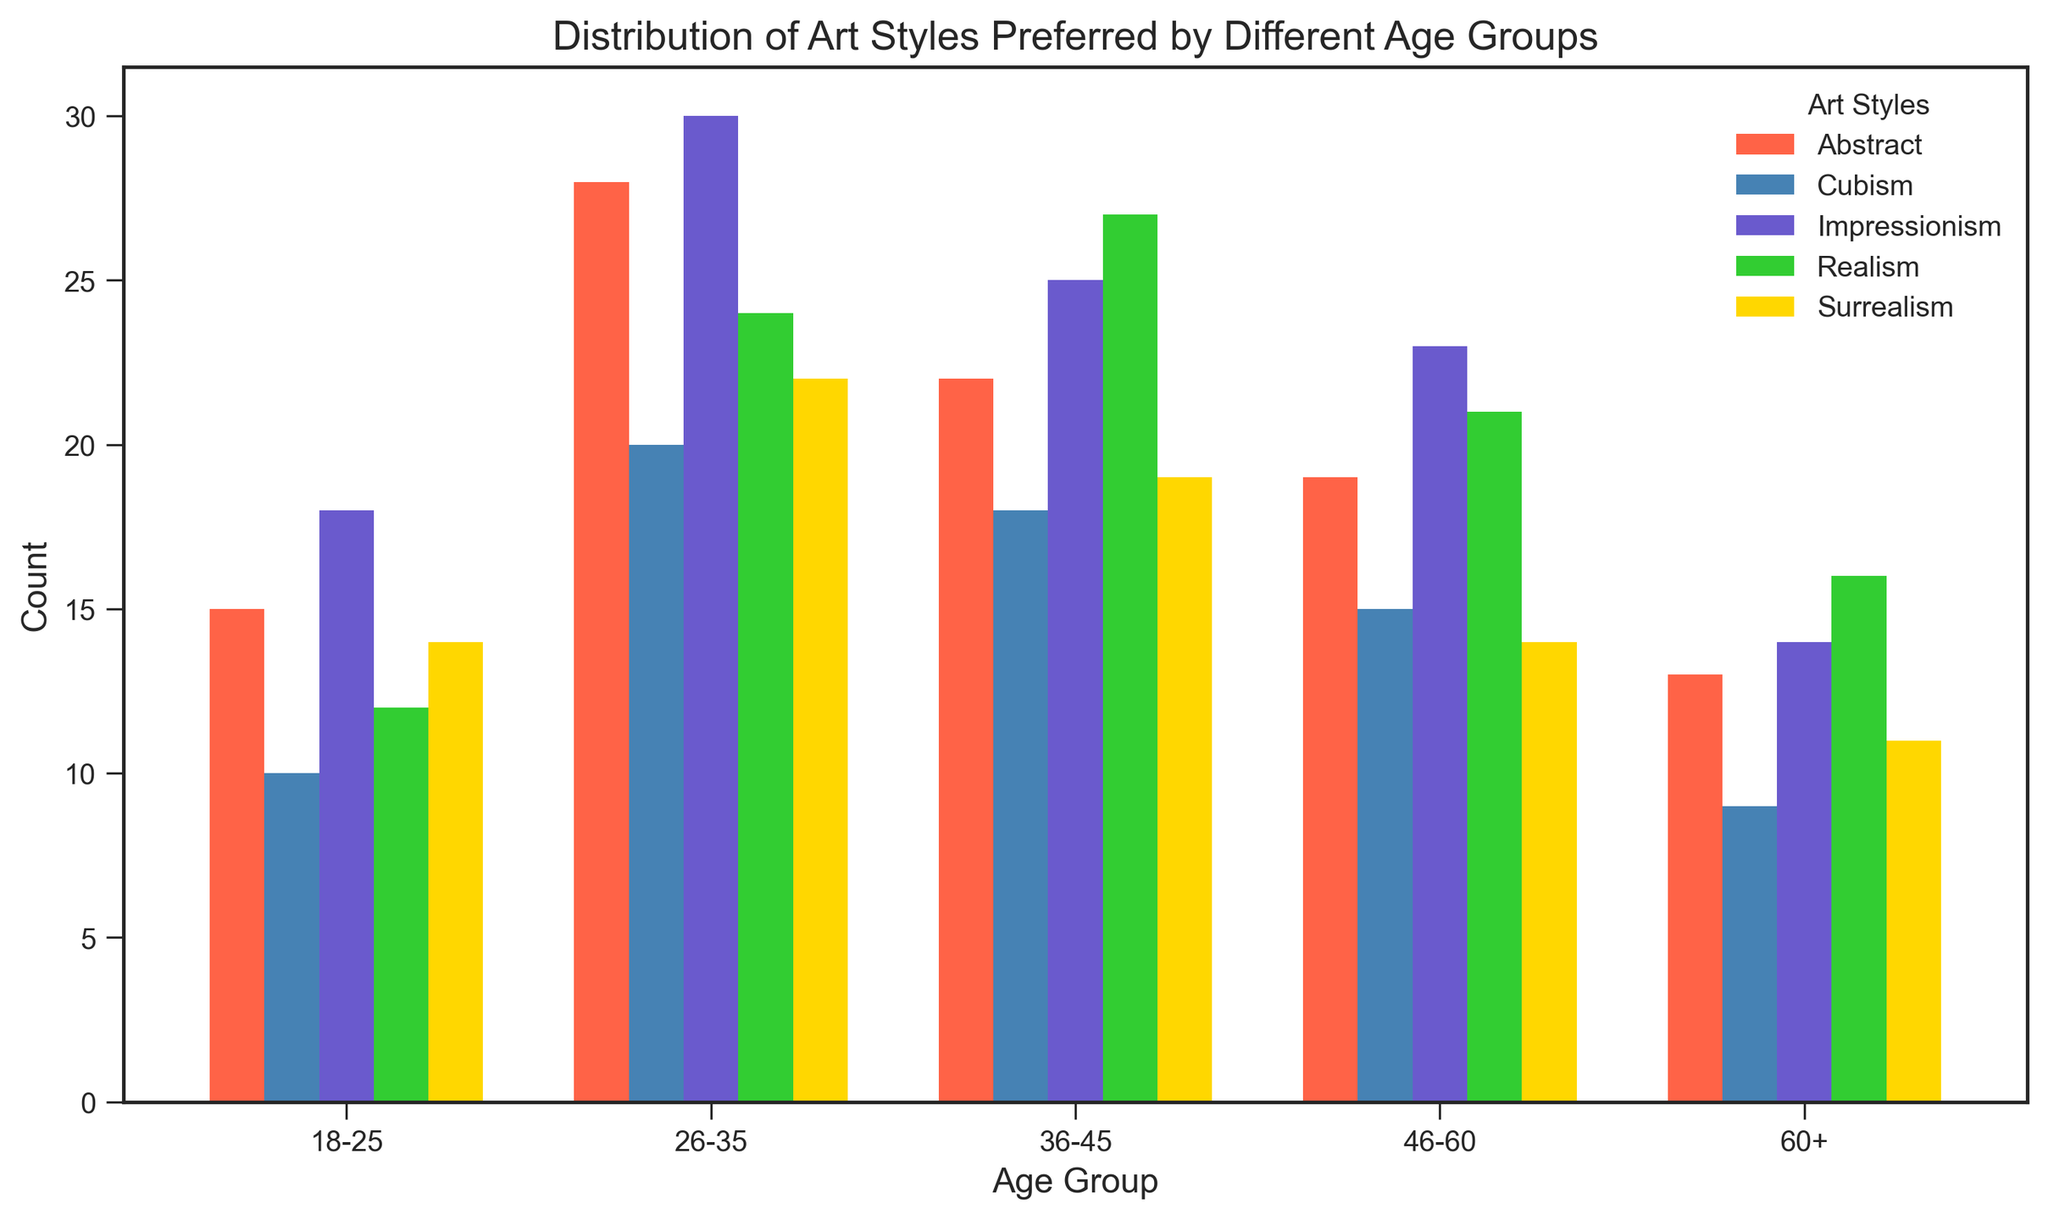Which age group has the highest preference for Abstract art? Refer to the height of the bars representing Abstract art in each age group. The tallest bar is for the 26-35 age group.
Answer: 26-35 Comparing Impressionism and Realism within the 36-45 age group, which Art Style has a higher count? Look at the height of the bars for Impressionism and Realism within the 36-45 age group. The bar for Realism is taller.
Answer: Realism What is the total count of individuals preferring Cubism across all age groups? Add the counts across all age groups for Cubism: 10 (18-25) + 20 (26-35) + 18 (36-45) + 15 (46-60) + 9 (60+) = 72.
Answer: 72 Which art style shows a declining trend in preference with increasing age groups? Observe and compare the height of bars for each art style across age groups. Surrealism shows a decline in the number of individuals as the age groups increase.
Answer: Surrealism How does the preference for Realism change from the 26-35 age group to the 60+ age group? Compare the heights of the bars for Realism in the 26-35 age group and the 60+ age group. There is a decrease from 24 (26-35) to 16 (60+).
Answer: Decreases In the 46-60 age group, which art style is the second most preferred after Impressionism? After observing the height of the bars in the 46-60 age group, Impressionism has the highest count. The second highest is Realism.
Answer: Realism Calculate the average number of individuals preferring each art style in the 18-25 age group. Add the counts for each art style in the 18-25 age group: Abstract (15) + Realism (12) + Impressionism (18) + Cubism (10) + Surrealism (14) = 69. Divide by the number of art styles (5). 69/5 = 13.8.
Answer: 13.8 Which art style is least preferred by the 60+ age group? The shortest bar in the 60+ age group represents Cubism with a count of 9.
Answer: Cubism What is the difference in preference for Impressionism between the 26-35 and 60+ age groups? Subtract the count in the 60+ age group from that in the 26-35 age group for Impressionism: 30 (26-35) - 14 (60+) = 16.
Answer: 16 For the 36-45 age group, which art styles have counts greater than 20? The bars for Abstract (22), Realism (27), and Impressionism (25) are greater than 20 for the 36-45 age group.
Answer: Abstract, Realism, and Impressionism 